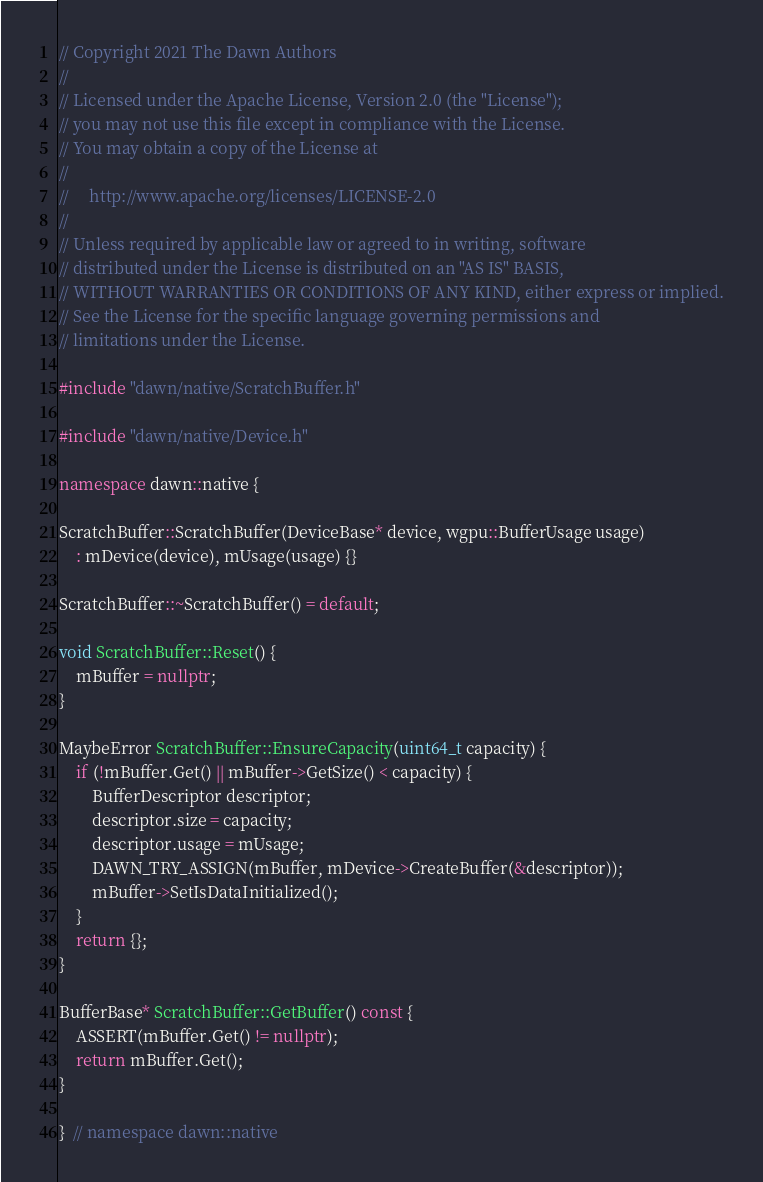Convert code to text. <code><loc_0><loc_0><loc_500><loc_500><_C++_>// Copyright 2021 The Dawn Authors
//
// Licensed under the Apache License, Version 2.0 (the "License");
// you may not use this file except in compliance with the License.
// You may obtain a copy of the License at
//
//     http://www.apache.org/licenses/LICENSE-2.0
//
// Unless required by applicable law or agreed to in writing, software
// distributed under the License is distributed on an "AS IS" BASIS,
// WITHOUT WARRANTIES OR CONDITIONS OF ANY KIND, either express or implied.
// See the License for the specific language governing permissions and
// limitations under the License.

#include "dawn/native/ScratchBuffer.h"

#include "dawn/native/Device.h"

namespace dawn::native {

ScratchBuffer::ScratchBuffer(DeviceBase* device, wgpu::BufferUsage usage)
    : mDevice(device), mUsage(usage) {}

ScratchBuffer::~ScratchBuffer() = default;

void ScratchBuffer::Reset() {
    mBuffer = nullptr;
}

MaybeError ScratchBuffer::EnsureCapacity(uint64_t capacity) {
    if (!mBuffer.Get() || mBuffer->GetSize() < capacity) {
        BufferDescriptor descriptor;
        descriptor.size = capacity;
        descriptor.usage = mUsage;
        DAWN_TRY_ASSIGN(mBuffer, mDevice->CreateBuffer(&descriptor));
        mBuffer->SetIsDataInitialized();
    }
    return {};
}

BufferBase* ScratchBuffer::GetBuffer() const {
    ASSERT(mBuffer.Get() != nullptr);
    return mBuffer.Get();
}

}  // namespace dawn::native
</code> 